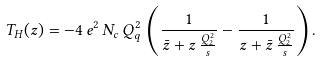<formula> <loc_0><loc_0><loc_500><loc_500>T _ { H } ( z ) = - 4 \, e ^ { 2 } \, N _ { c } \, Q _ { q } ^ { 2 } \, \left ( \frac { 1 } { \bar { z } + z \, \frac { Q _ { 2 } ^ { 2 } } { s } } - \frac { 1 } { z + \bar { z } \, \frac { Q _ { 2 } ^ { 2 } } { s } } \right ) .</formula> 